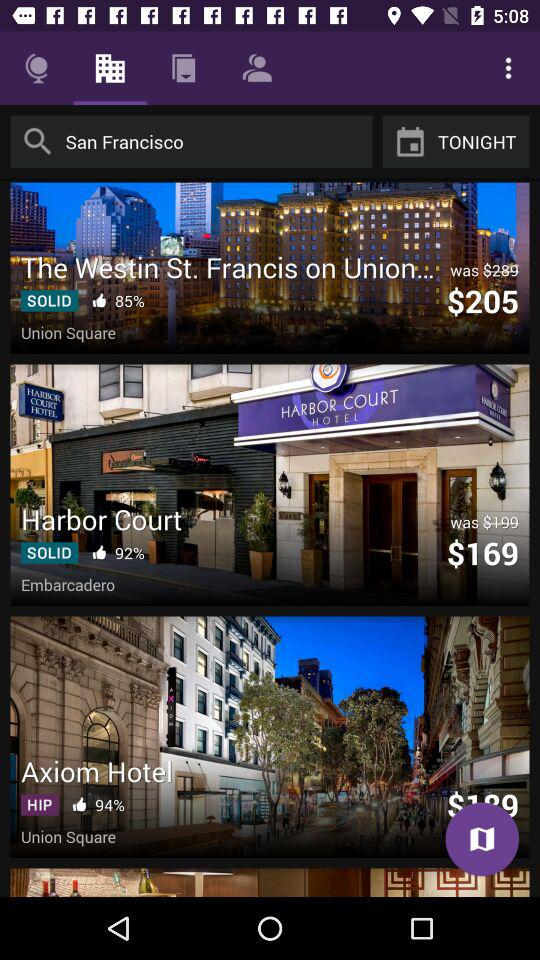For travelers interested in vibrant nightlife and social scenes, which hotel would you recommend? Travelers interested in vibrant nightlife and social scenes might prefer the 'Axiom Hotel'. Labelled as 'HIP' with a high recommendation score, it suggests a trendy, modern vibe and is likely to be located near lively nightspots, trendy bars, and social venues around Union Square. 